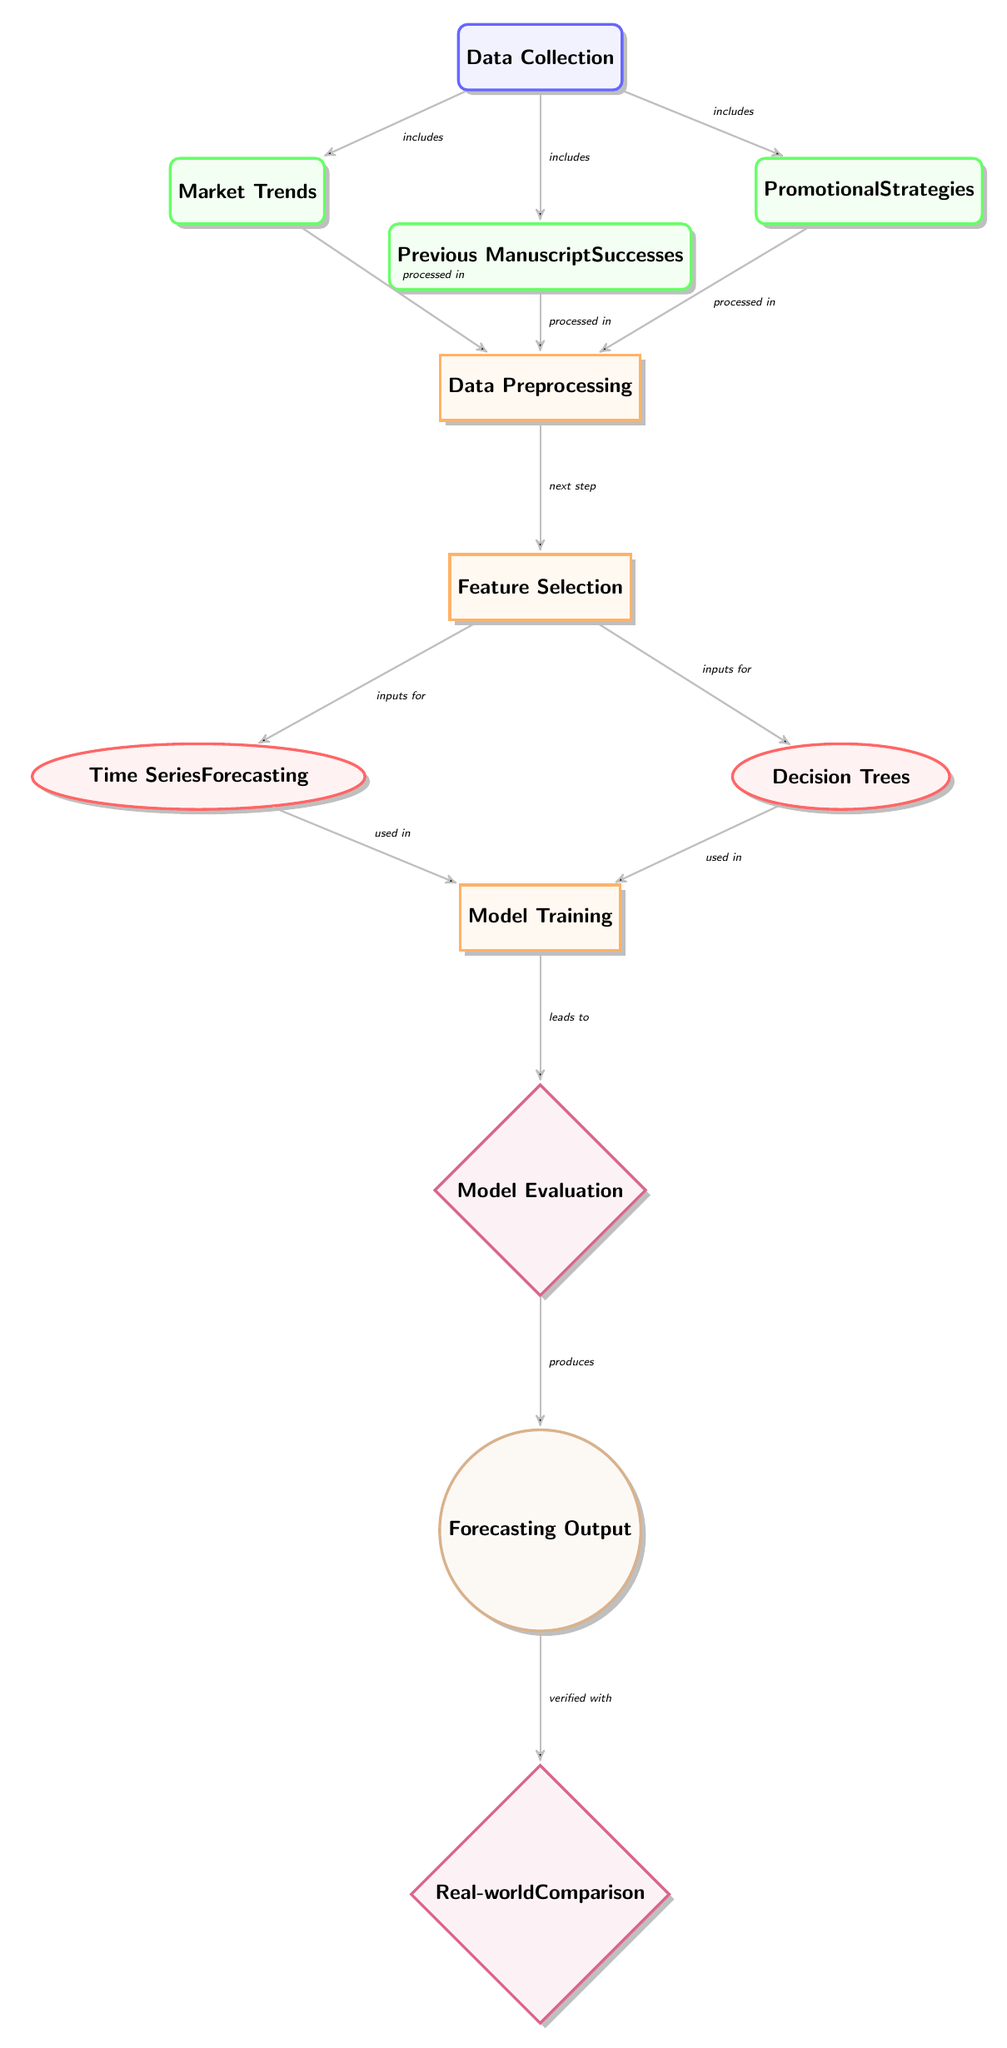What are the three main features included in the data collection? The diagram labels three features: Market Trends, Previous Manuscript Successes, and Promotional Strategies, all originating from the Data Collection node.
Answer: Market Trends, Previous Manuscript Successes, Promotional Strategies How many processing steps are illustrated in the diagram? The diagram indicates three processing steps below the Data Preprocessing node: Data Preprocessing, Feature Selection, and Model Training. There are also two evaluation steps afterwards.
Answer: Three What type of model is used alongside time series forecasting in this diagram? The diagram shows that Decision Trees is the second model type used alongside Time Series Forecasting in the Model section.
Answer: Decision Trees How does the output of the model evaluation relate to real-world comparison? The output of the Model Evaluation node produces the Forecasting Output, which is then verified with the Real-world Comparison node, indicating a connection between model evaluation output and real-world validation.
Answer: Verified with What are the inputs for the model training step? The inputs for Model Training come from both Time Series Forecasting and Decision Trees, as shown by the arrows indicating that these models contribute to Model Training.
Answer: Time Series Forecasting, Decision Trees Which step comes after data preprocessing? The diagram establishes Feature Selection as the next step following Data Preprocessing, as indicated by the arrow leading from one to the other.
Answer: Feature Selection Which elements are considered data for this diagram? The elements considered as data in the diagram are Market Trends, Previous Manuscript Successes, and Promotional Strategies, all part of the Data Collection phase.
Answer: Market Trends, Previous Manuscript Successes, Promotional Strategies What is the final output of the diagram? The diagram specifies that the final output generated through the specified processes is the Forecasting Output, which also leads to a Real-world Comparison.
Answer: Forecasting Output 